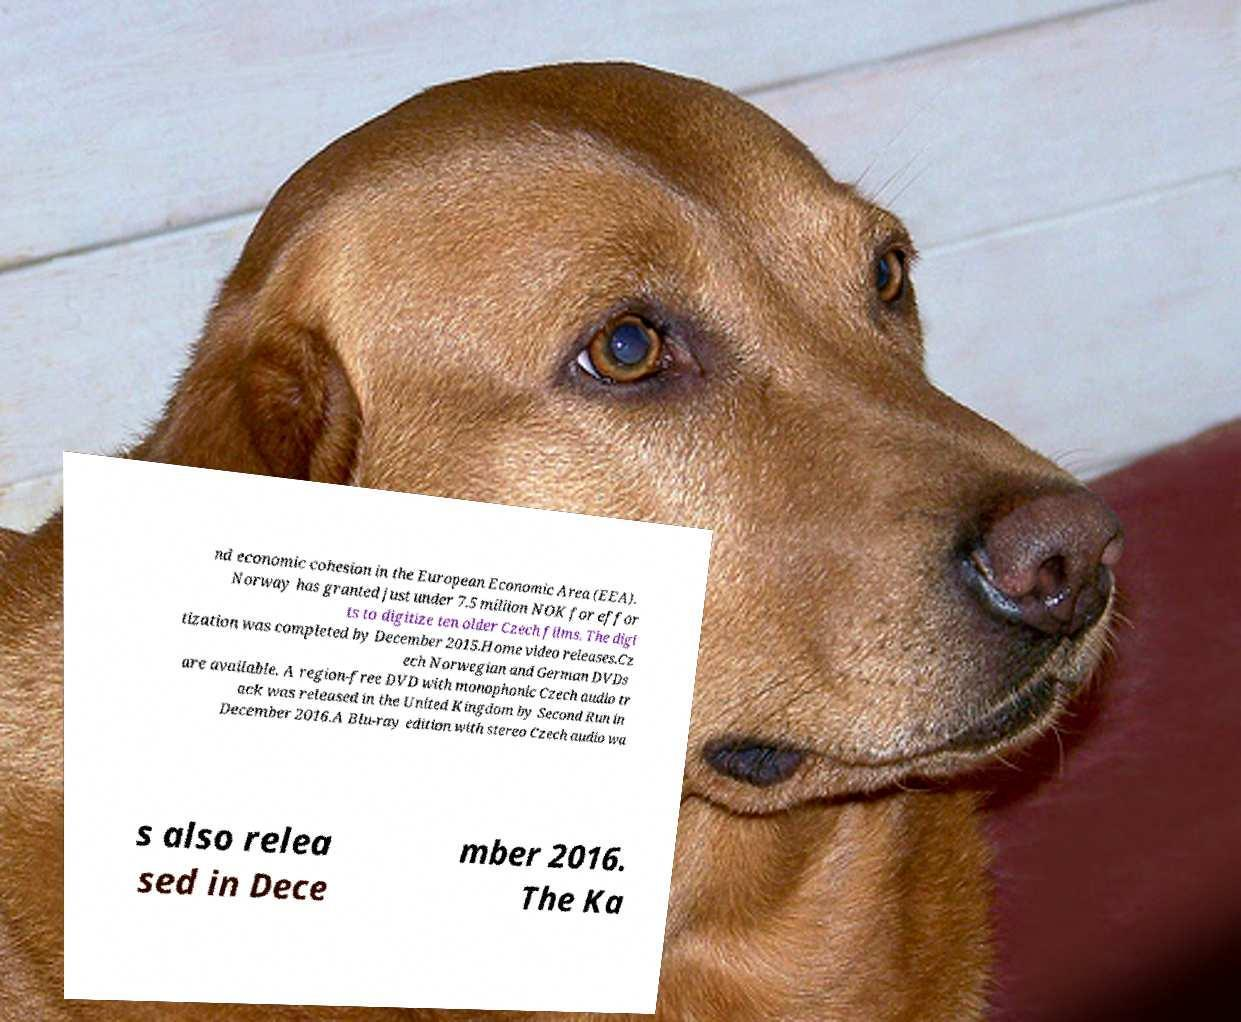Can you read and provide the text displayed in the image?This photo seems to have some interesting text. Can you extract and type it out for me? nd economic cohesion in the European Economic Area (EEA). Norway has granted just under 7.5 million NOK for effor ts to digitize ten older Czech films. The digi tization was completed by December 2015.Home video releases.Cz ech Norwegian and German DVDs are available. A region-free DVD with monophonic Czech audio tr ack was released in the United Kingdom by Second Run in December 2016.A Blu-ray edition with stereo Czech audio wa s also relea sed in Dece mber 2016. The Ka 